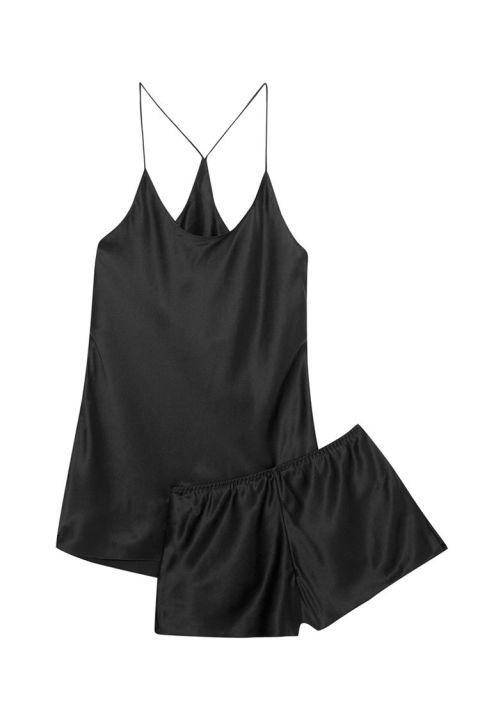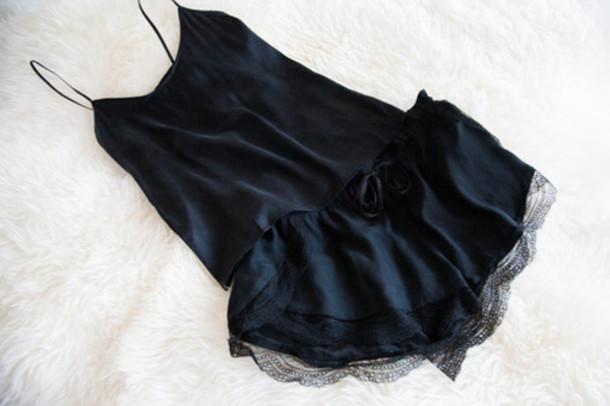The first image is the image on the left, the second image is the image on the right. Evaluate the accuracy of this statement regarding the images: "There is one set of lingerie in the image on the left.". Is it true? Answer yes or no. Yes. The first image is the image on the left, the second image is the image on the right. For the images shown, is this caption "Images feature matching dark lingerie sets and peachy colored sets, but none are worn by human models." true? Answer yes or no. No. 